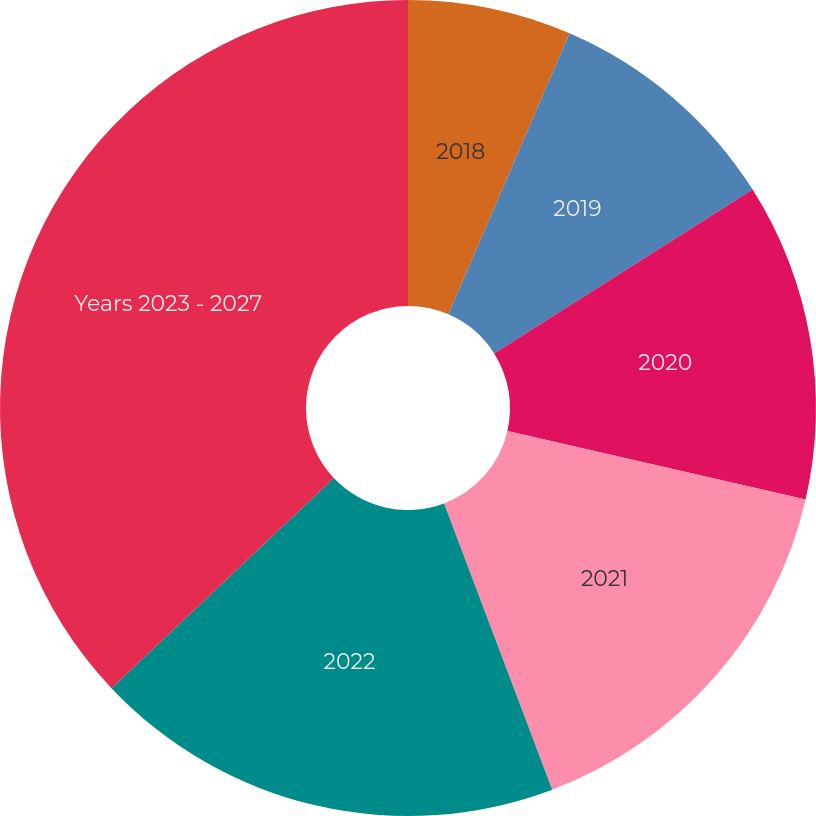Convert chart to OTSL. <chart><loc_0><loc_0><loc_500><loc_500><pie_chart><fcel>2018<fcel>2019<fcel>2020<fcel>2021<fcel>2022<fcel>Years 2023 - 2027<nl><fcel>6.48%<fcel>9.53%<fcel>12.59%<fcel>15.65%<fcel>18.7%<fcel>37.05%<nl></chart> 